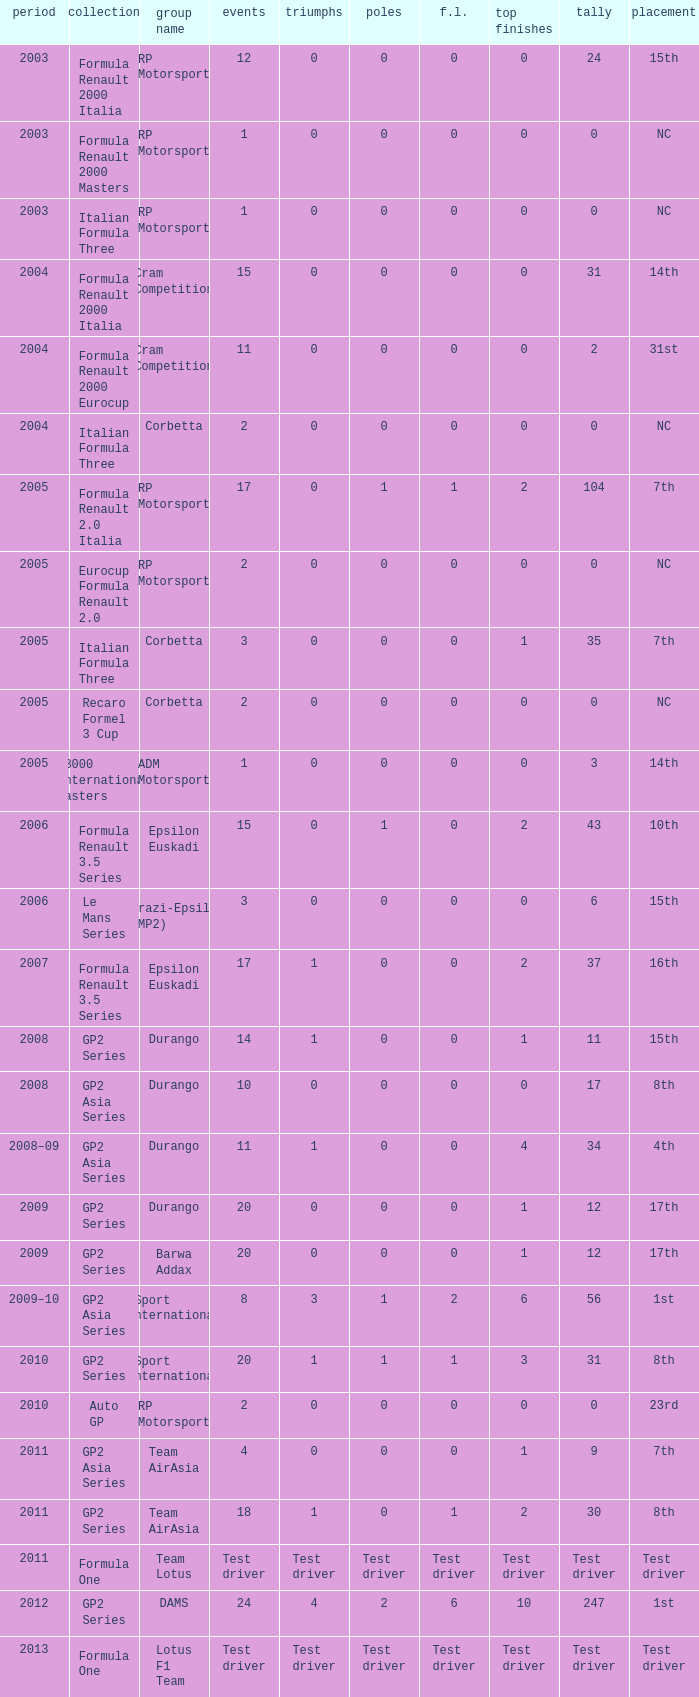What is the number of poles with 104 points? 1.0. 